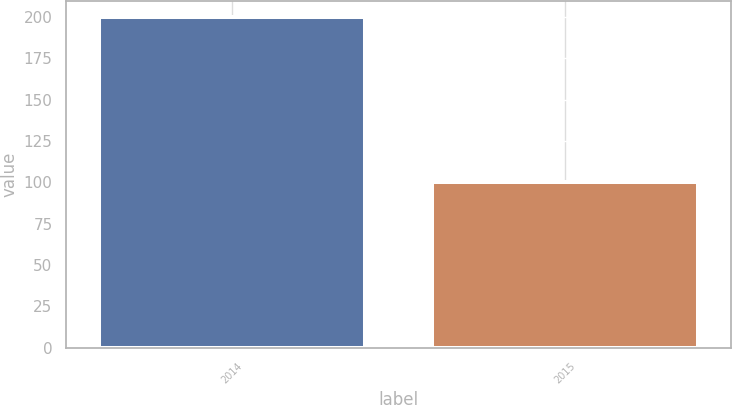Convert chart to OTSL. <chart><loc_0><loc_0><loc_500><loc_500><bar_chart><fcel>2014<fcel>2015<nl><fcel>200<fcel>100<nl></chart> 